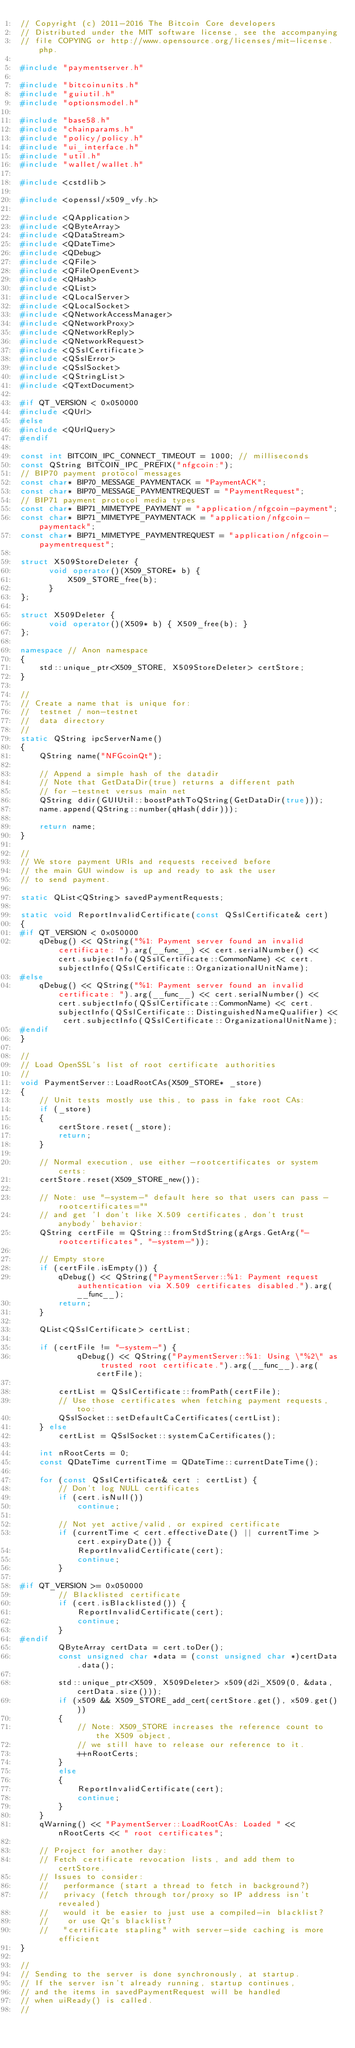Convert code to text. <code><loc_0><loc_0><loc_500><loc_500><_C++_>// Copyright (c) 2011-2016 The Bitcoin Core developers
// Distributed under the MIT software license, see the accompanying
// file COPYING or http://www.opensource.org/licenses/mit-license.php.

#include "paymentserver.h"

#include "bitcoinunits.h"
#include "guiutil.h"
#include "optionsmodel.h"

#include "base58.h"
#include "chainparams.h"
#include "policy/policy.h"
#include "ui_interface.h"
#include "util.h"
#include "wallet/wallet.h"

#include <cstdlib>

#include <openssl/x509_vfy.h>

#include <QApplication>
#include <QByteArray>
#include <QDataStream>
#include <QDateTime>
#include <QDebug>
#include <QFile>
#include <QFileOpenEvent>
#include <QHash>
#include <QList>
#include <QLocalServer>
#include <QLocalSocket>
#include <QNetworkAccessManager>
#include <QNetworkProxy>
#include <QNetworkReply>
#include <QNetworkRequest>
#include <QSslCertificate>
#include <QSslError>
#include <QSslSocket>
#include <QStringList>
#include <QTextDocument>

#if QT_VERSION < 0x050000
#include <QUrl>
#else
#include <QUrlQuery>
#endif

const int BITCOIN_IPC_CONNECT_TIMEOUT = 1000; // milliseconds
const QString BITCOIN_IPC_PREFIX("nfgcoin:");
// BIP70 payment protocol messages
const char* BIP70_MESSAGE_PAYMENTACK = "PaymentACK";
const char* BIP70_MESSAGE_PAYMENTREQUEST = "PaymentRequest";
// BIP71 payment protocol media types
const char* BIP71_MIMETYPE_PAYMENT = "application/nfgcoin-payment";
const char* BIP71_MIMETYPE_PAYMENTACK = "application/nfgcoin-paymentack";
const char* BIP71_MIMETYPE_PAYMENTREQUEST = "application/nfgcoin-paymentrequest";

struct X509StoreDeleter {
      void operator()(X509_STORE* b) {
          X509_STORE_free(b);
      }
};

struct X509Deleter {
      void operator()(X509* b) { X509_free(b); }
};

namespace // Anon namespace
{
    std::unique_ptr<X509_STORE, X509StoreDeleter> certStore;
}

//
// Create a name that is unique for:
//  testnet / non-testnet
//  data directory
//
static QString ipcServerName()
{
    QString name("NFGcoinQt");

    // Append a simple hash of the datadir
    // Note that GetDataDir(true) returns a different path
    // for -testnet versus main net
    QString ddir(GUIUtil::boostPathToQString(GetDataDir(true)));
    name.append(QString::number(qHash(ddir)));

    return name;
}

//
// We store payment URIs and requests received before
// the main GUI window is up and ready to ask the user
// to send payment.

static QList<QString> savedPaymentRequests;

static void ReportInvalidCertificate(const QSslCertificate& cert)
{
#if QT_VERSION < 0x050000
    qDebug() << QString("%1: Payment server found an invalid certificate: ").arg(__func__) << cert.serialNumber() << cert.subjectInfo(QSslCertificate::CommonName) << cert.subjectInfo(QSslCertificate::OrganizationalUnitName);
#else
    qDebug() << QString("%1: Payment server found an invalid certificate: ").arg(__func__) << cert.serialNumber() << cert.subjectInfo(QSslCertificate::CommonName) << cert.subjectInfo(QSslCertificate::DistinguishedNameQualifier) << cert.subjectInfo(QSslCertificate::OrganizationalUnitName);
#endif
}

//
// Load OpenSSL's list of root certificate authorities
//
void PaymentServer::LoadRootCAs(X509_STORE* _store)
{
    // Unit tests mostly use this, to pass in fake root CAs:
    if (_store)
    {
        certStore.reset(_store);
        return;
    }

    // Normal execution, use either -rootcertificates or system certs:
    certStore.reset(X509_STORE_new());

    // Note: use "-system-" default here so that users can pass -rootcertificates=""
    // and get 'I don't like X.509 certificates, don't trust anybody' behavior:
    QString certFile = QString::fromStdString(gArgs.GetArg("-rootcertificates", "-system-"));

    // Empty store
    if (certFile.isEmpty()) {
        qDebug() << QString("PaymentServer::%1: Payment request authentication via X.509 certificates disabled.").arg(__func__);
        return;
    }

    QList<QSslCertificate> certList;

    if (certFile != "-system-") {
            qDebug() << QString("PaymentServer::%1: Using \"%2\" as trusted root certificate.").arg(__func__).arg(certFile);

        certList = QSslCertificate::fromPath(certFile);
        // Use those certificates when fetching payment requests, too:
        QSslSocket::setDefaultCaCertificates(certList);
    } else
        certList = QSslSocket::systemCaCertificates();

    int nRootCerts = 0;
    const QDateTime currentTime = QDateTime::currentDateTime();

    for (const QSslCertificate& cert : certList) {
        // Don't log NULL certificates
        if (cert.isNull())
            continue;

        // Not yet active/valid, or expired certificate
        if (currentTime < cert.effectiveDate() || currentTime > cert.expiryDate()) {
            ReportInvalidCertificate(cert);
            continue;
        }

#if QT_VERSION >= 0x050000
        // Blacklisted certificate
        if (cert.isBlacklisted()) {
            ReportInvalidCertificate(cert);
            continue;
        }
#endif
        QByteArray certData = cert.toDer();
        const unsigned char *data = (const unsigned char *)certData.data();

        std::unique_ptr<X509, X509Deleter> x509(d2i_X509(0, &data, certData.size()));
        if (x509 && X509_STORE_add_cert(certStore.get(), x509.get()))
        {
            // Note: X509_STORE increases the reference count to the X509 object,
            // we still have to release our reference to it.
            ++nRootCerts;
        }
        else
        {
            ReportInvalidCertificate(cert);
            continue;
        }
    }
    qWarning() << "PaymentServer::LoadRootCAs: Loaded " << nRootCerts << " root certificates";

    // Project for another day:
    // Fetch certificate revocation lists, and add them to certStore.
    // Issues to consider:
    //   performance (start a thread to fetch in background?)
    //   privacy (fetch through tor/proxy so IP address isn't revealed)
    //   would it be easier to just use a compiled-in blacklist?
    //    or use Qt's blacklist?
    //   "certificate stapling" with server-side caching is more efficient
}

//
// Sending to the server is done synchronously, at startup.
// If the server isn't already running, startup continues,
// and the items in savedPaymentRequest will be handled
// when uiReady() is called.
//</code> 